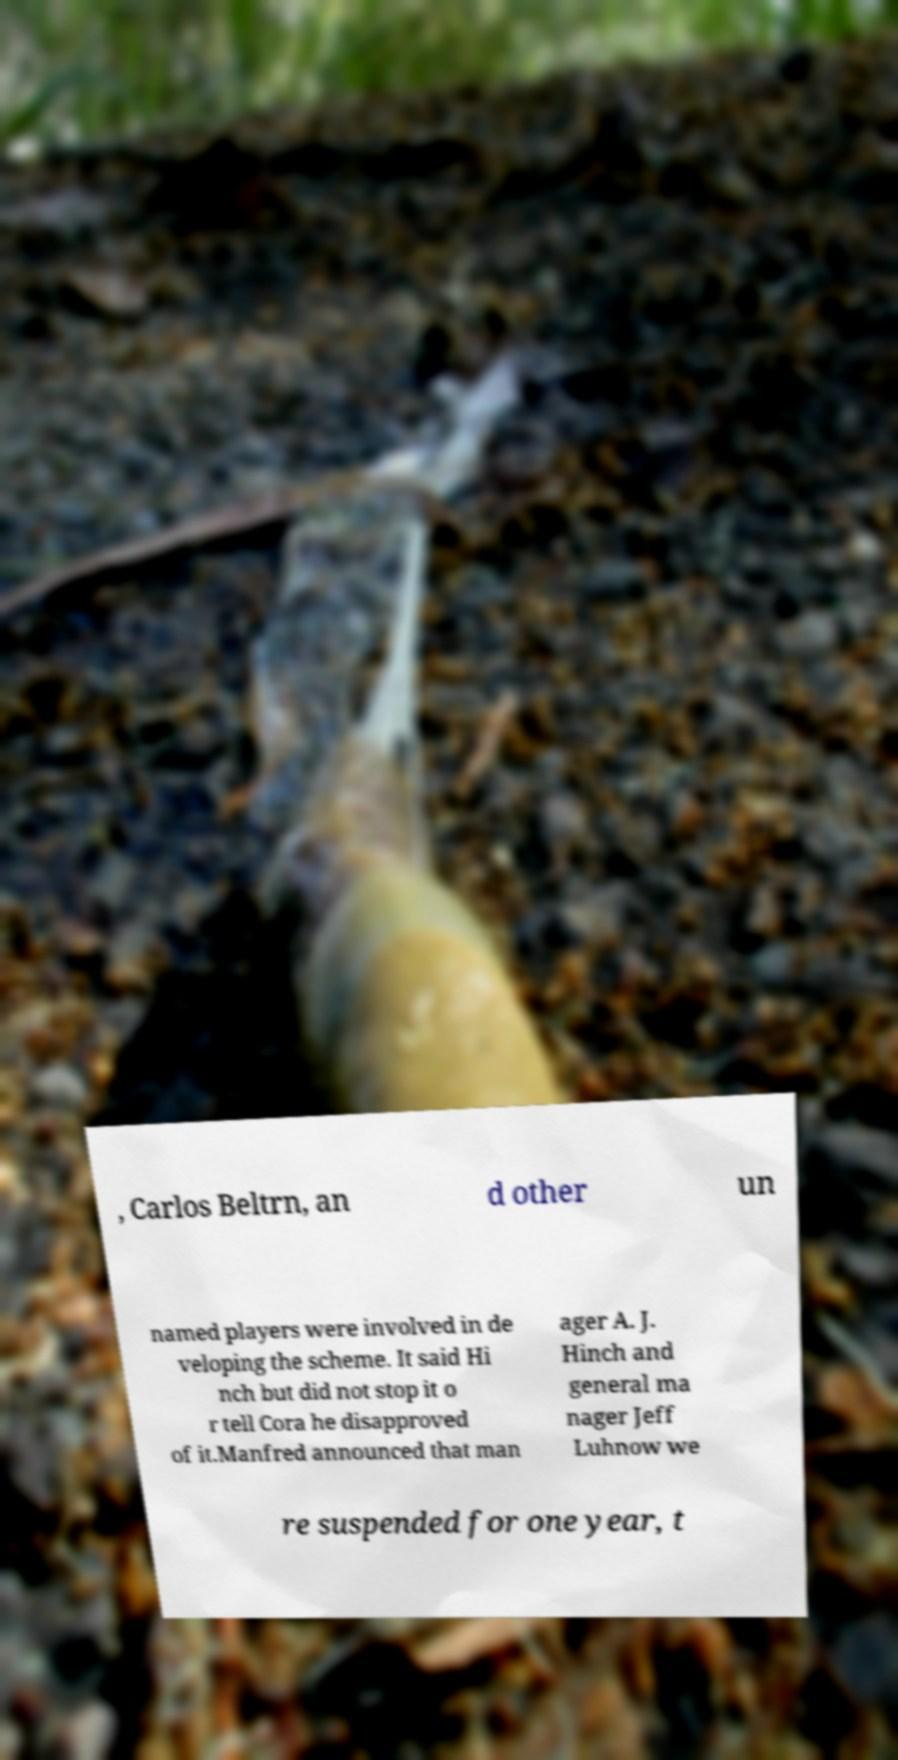Can you read and provide the text displayed in the image?This photo seems to have some interesting text. Can you extract and type it out for me? , Carlos Beltrn, an d other un named players were involved in de veloping the scheme. It said Hi nch but did not stop it o r tell Cora he disapproved of it.Manfred announced that man ager A. J. Hinch and general ma nager Jeff Luhnow we re suspended for one year, t 